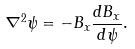Convert formula to latex. <formula><loc_0><loc_0><loc_500><loc_500>\nabla ^ { 2 } \psi = - B _ { x } \frac { d B _ { x } } { d \psi } .</formula> 